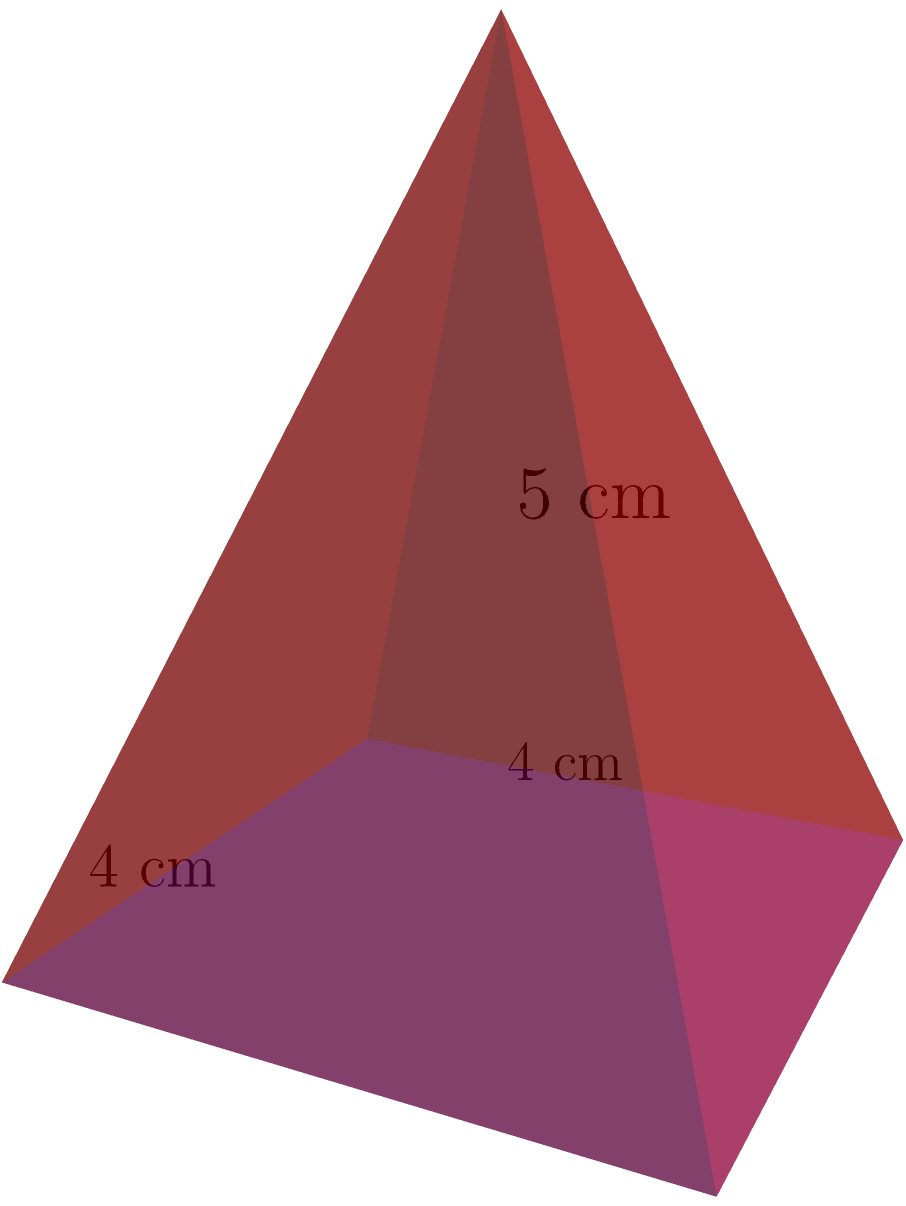As a music critic, you've been asked to present an award at the "Indie Music Excellence Awards." The trophy is a pyramid-shaped crystal with a square base. If the base is 4 cm on each side and the height of the pyramid is 5 cm, what is the total surface area of the trophy in square centimeters? Round your answer to two decimal places. Let's approach this step-by-step:

1) The surface area of a pyramid consists of the area of the base plus the area of the four triangular faces.

2) Area of the base:
   $A_{base} = 4 \text{ cm} \times 4 \text{ cm} = 16 \text{ cm}^2$

3) For the triangular faces, we need to find their height (slant height):
   Let's call the slant height $s$.
   Using the Pythagorean theorem:
   $s^2 = 5^2 + 2^2$ (where 2 is half the base diagonal)
   $s^2 = 25 + 4 = 29$
   $s = \sqrt{29} \approx 5.385 \text{ cm}$

4) Area of each triangular face:
   $A_{face} = \frac{1}{2} \times 4 \text{ cm} \times 5.385 \text{ cm} = 10.77 \text{ cm}^2$

5) Total area of the four triangular faces:
   $A_{faces} = 4 \times 10.77 \text{ cm}^2 = 43.08 \text{ cm}^2$

6) Total surface area:
   $A_{total} = A_{base} + A_{faces} = 16 \text{ cm}^2 + 43.08 \text{ cm}^2 = 59.08 \text{ cm}^2$

7) Rounding to two decimal places: 59.08 cm²
Answer: 59.08 cm² 